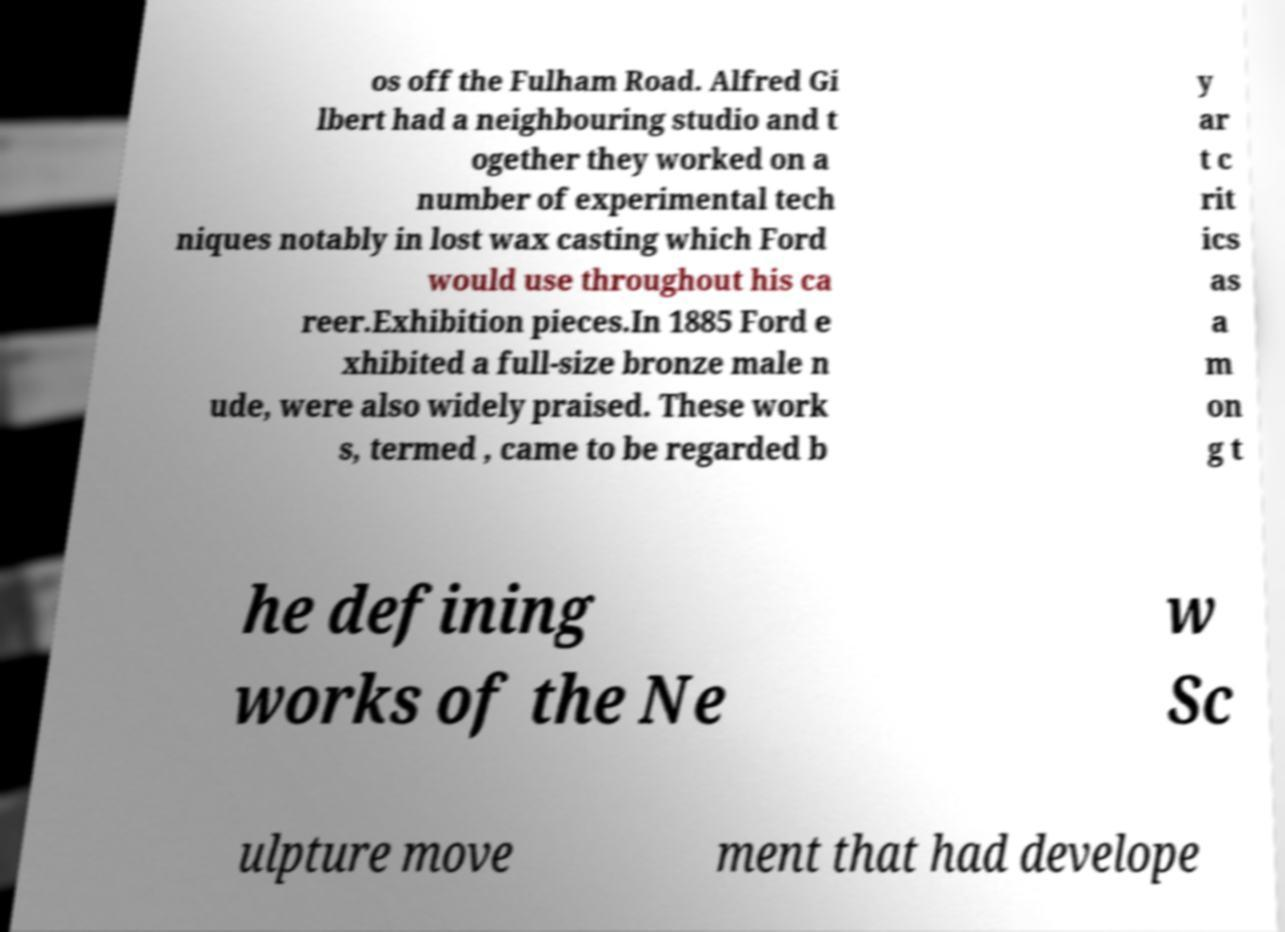Please read and relay the text visible in this image. What does it say? os off the Fulham Road. Alfred Gi lbert had a neighbouring studio and t ogether they worked on a number of experimental tech niques notably in lost wax casting which Ford would use throughout his ca reer.Exhibition pieces.In 1885 Ford e xhibited a full-size bronze male n ude, were also widely praised. These work s, termed , came to be regarded b y ar t c rit ics as a m on g t he defining works of the Ne w Sc ulpture move ment that had develope 